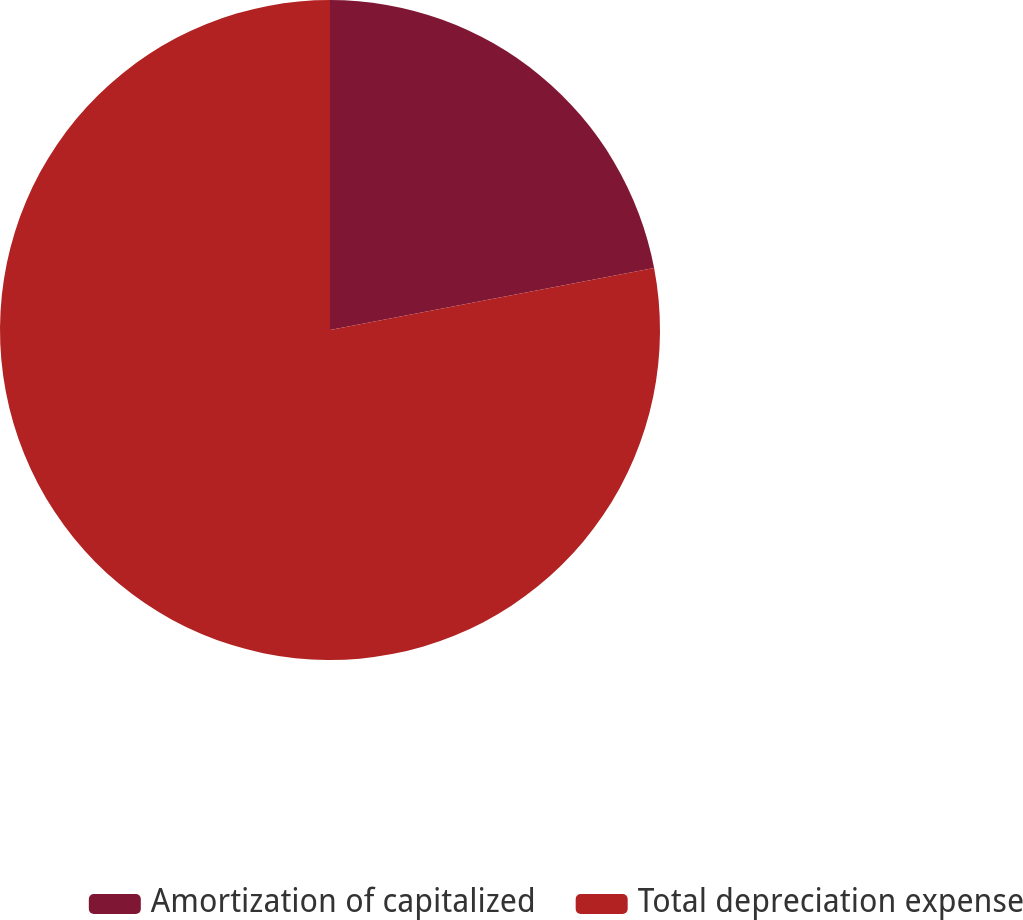Convert chart to OTSL. <chart><loc_0><loc_0><loc_500><loc_500><pie_chart><fcel>Amortization of capitalized<fcel>Total depreciation expense<nl><fcel>21.99%<fcel>78.01%<nl></chart> 